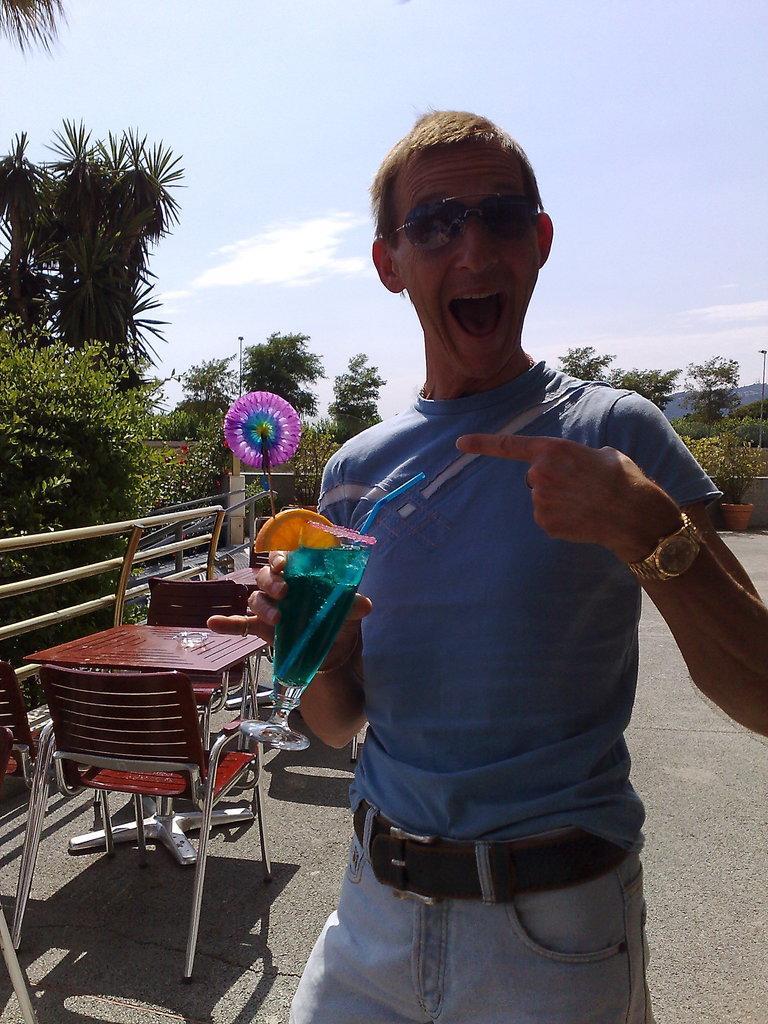Please provide a concise description of this image. In this image, I can see the man standing and holding a glass of liquid. On the left side of the image, there is a table and chairs. In the background, I can see the trees and the sky. 